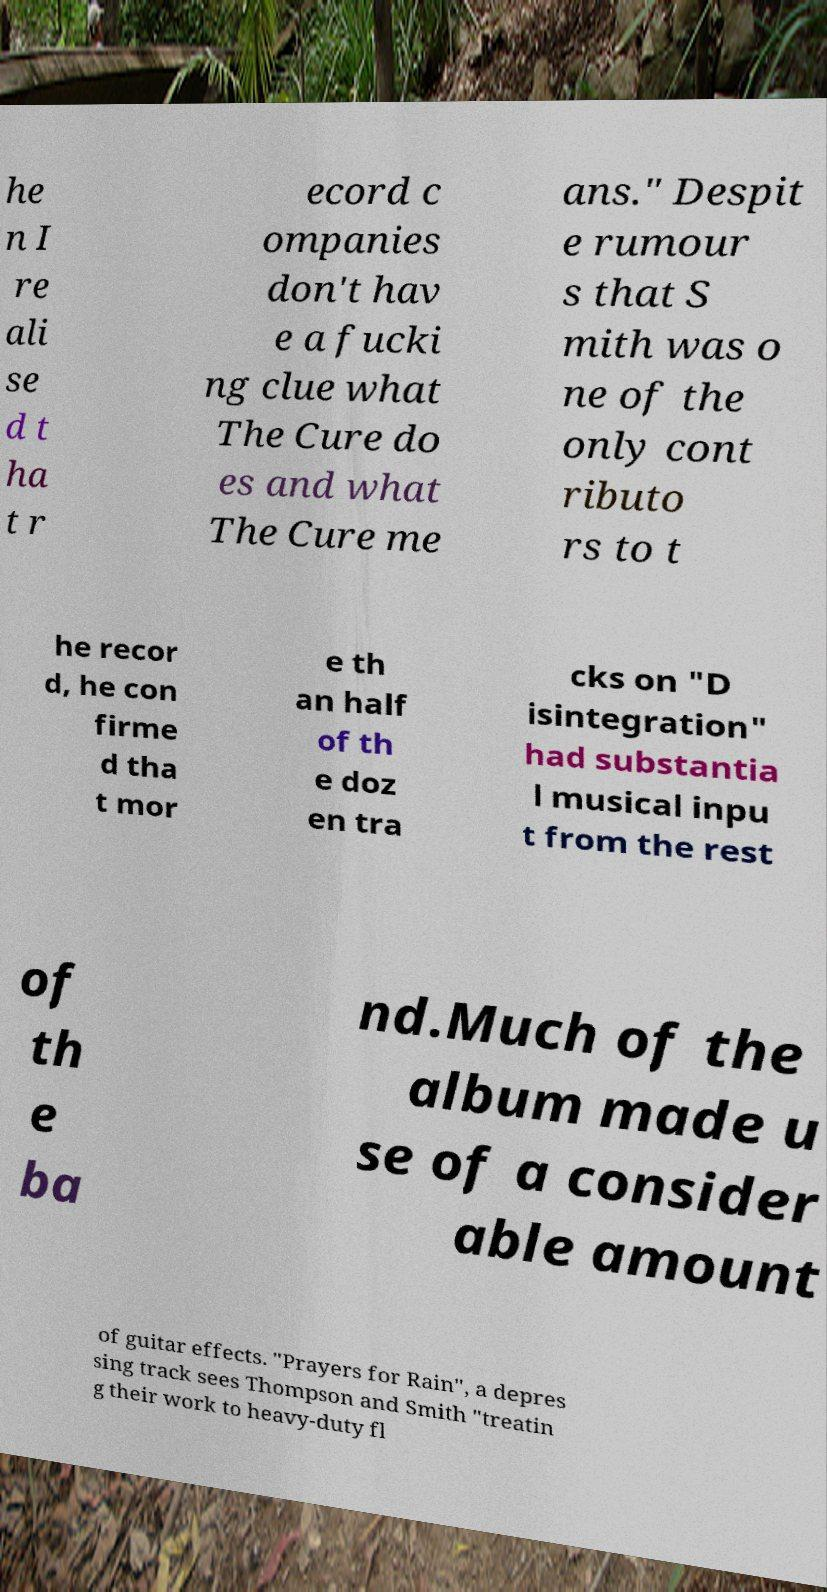Please read and relay the text visible in this image. What does it say? he n I re ali se d t ha t r ecord c ompanies don't hav e a fucki ng clue what The Cure do es and what The Cure me ans." Despit e rumour s that S mith was o ne of the only cont ributo rs to t he recor d, he con firme d tha t mor e th an half of th e doz en tra cks on "D isintegration" had substantia l musical inpu t from the rest of th e ba nd.Much of the album made u se of a consider able amount of guitar effects. "Prayers for Rain", a depres sing track sees Thompson and Smith "treatin g their work to heavy-duty fl 